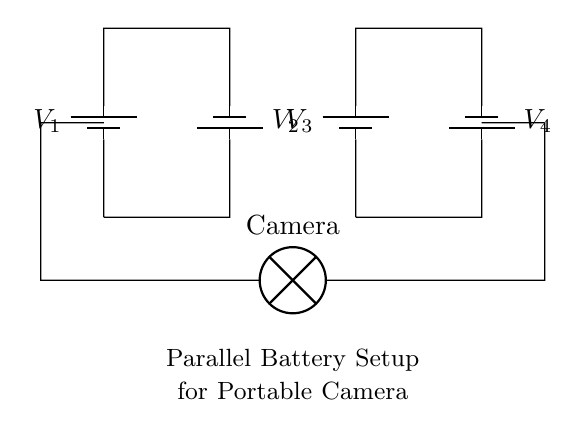What type of circuit is represented here? The circuit diagram shows a parallel battery circuit, indicated by the arrangement of batteries connected side by side, sharing the same voltage across them.
Answer: Parallel What is the total number of batteries used? There are a total of four batteries shown in the circuit diagram, all indicated by the battery symbols.
Answer: Four What component is connected to the batteries? The circuit connects a camera, as indicated by the lamp symbol labeled 'Camera' at the bottom of the diagram.
Answer: Camera What is the voltage across the camera? In a parallel setup, the voltage across each component is the same as the voltage of the batteries, which are labeled. Since they are in parallel, it implies one shared voltage level.
Answer: Same as the battery voltage How are the batteries connected? The batteries are arranged in parallel; this means each battery's positive terminal is connected to the positive terminal of another directly, and the same for the negative terminals.
Answer: In parallel What happens to the total voltage when adding more batteries in parallel? When batteries are added in parallel, the total voltage remains the same as a single battery, since all components share the same voltage level.
Answer: Stays the same 